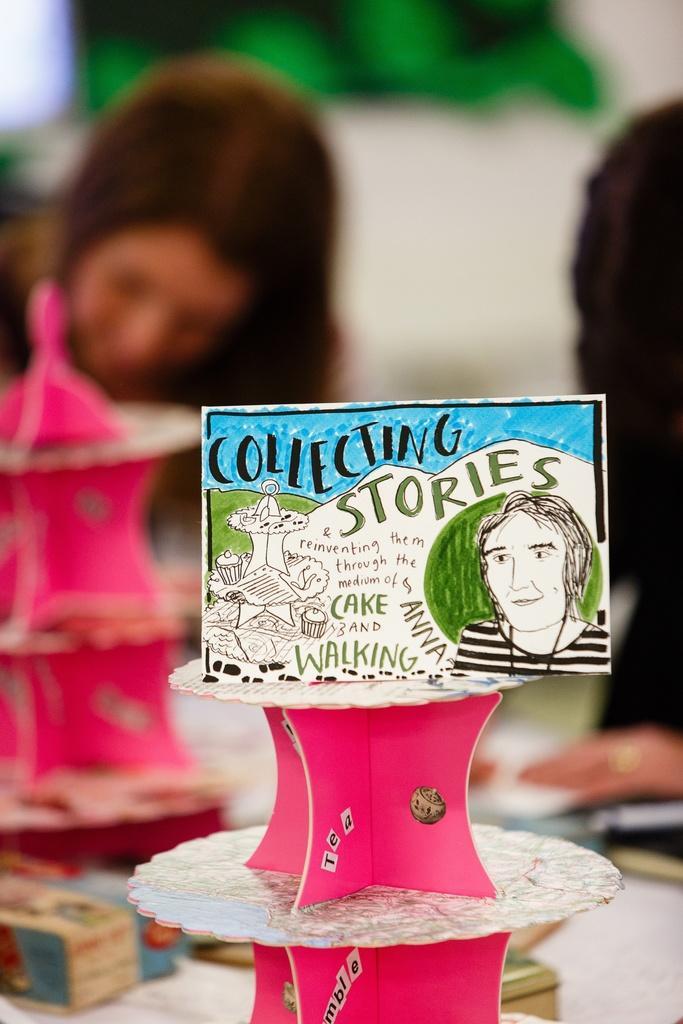Could you give a brief overview of what you see in this image? In this image we can see a board with text and image and we can see the pink color objects. We can see a person with blur background. 